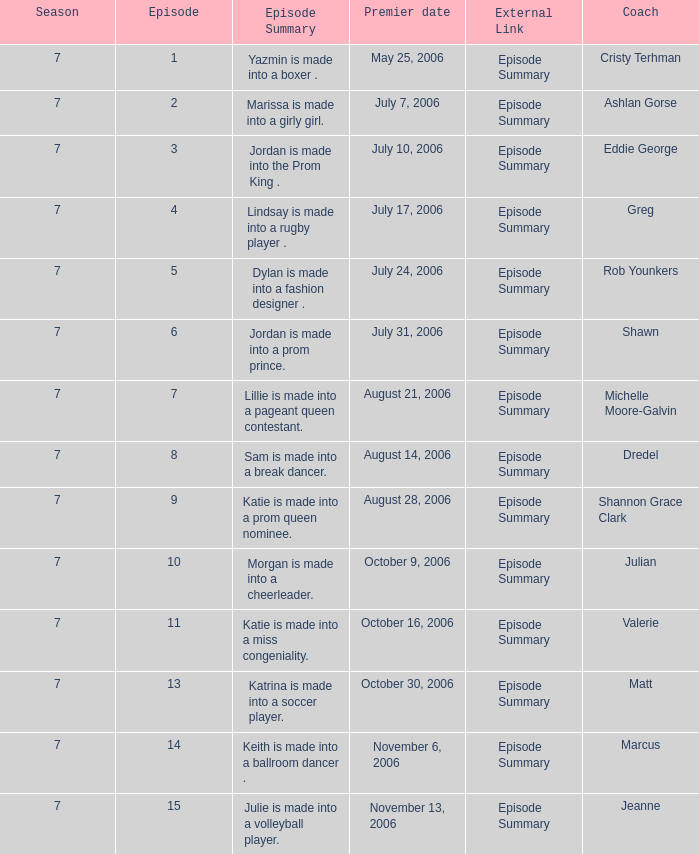What the summary of episode 15? Julie is made into a volleyball player. 